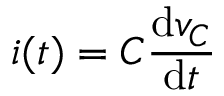<formula> <loc_0><loc_0><loc_500><loc_500>i ( t ) = C { \frac { d v _ { C } } { d t } }</formula> 